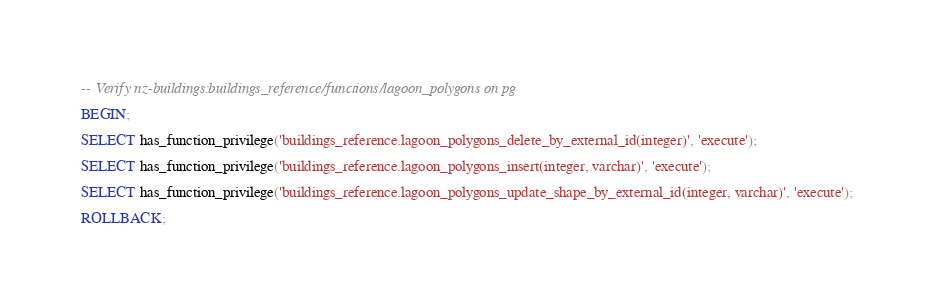Convert code to text. <code><loc_0><loc_0><loc_500><loc_500><_SQL_>-- Verify nz-buildings:buildings_reference/functions/lagoon_polygons on pg

BEGIN;

SELECT has_function_privilege('buildings_reference.lagoon_polygons_delete_by_external_id(integer)', 'execute');

SELECT has_function_privilege('buildings_reference.lagoon_polygons_insert(integer, varchar)', 'execute');

SELECT has_function_privilege('buildings_reference.lagoon_polygons_update_shape_by_external_id(integer, varchar)', 'execute');

ROLLBACK;
</code> 